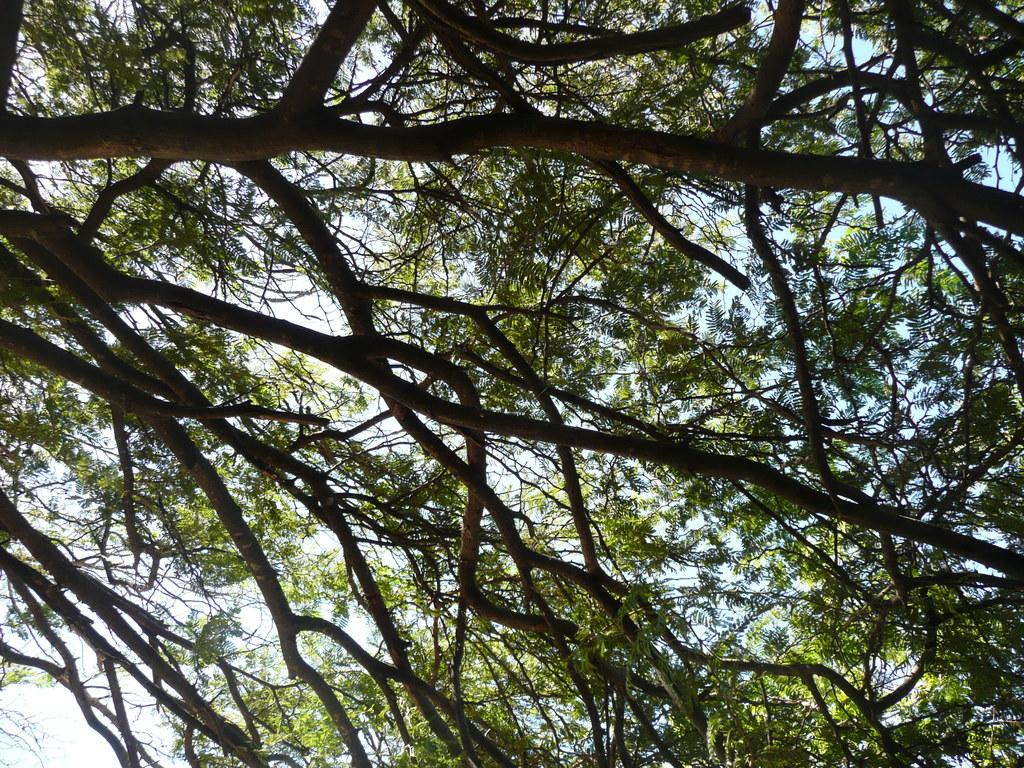What type of vegetation can be seen in the image? There are trees in the image. What part of the natural environment is visible in the image? The sky is visible in the background of the image. What type of fight is taking place between the trees in the image? There is no fight taking place between the trees in the image; they are simply standing in the landscape. 